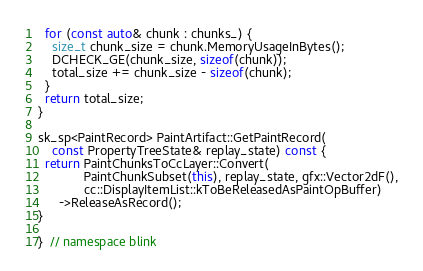<code> <loc_0><loc_0><loc_500><loc_500><_C++_>  for (const auto& chunk : chunks_) {
    size_t chunk_size = chunk.MemoryUsageInBytes();
    DCHECK_GE(chunk_size, sizeof(chunk));
    total_size += chunk_size - sizeof(chunk);
  }
  return total_size;
}

sk_sp<PaintRecord> PaintArtifact::GetPaintRecord(
    const PropertyTreeState& replay_state) const {
  return PaintChunksToCcLayer::Convert(
             PaintChunkSubset(this), replay_state, gfx::Vector2dF(),
             cc::DisplayItemList::kToBeReleasedAsPaintOpBuffer)
      ->ReleaseAsRecord();
}

}  // namespace blink
</code> 